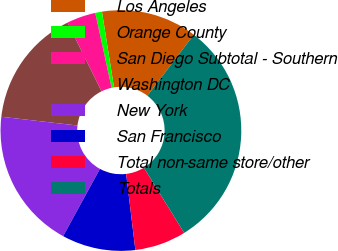<chart> <loc_0><loc_0><loc_500><loc_500><pie_chart><fcel>Los Angeles<fcel>Orange County<fcel>San Diego Subtotal - Southern<fcel>Washington DC<fcel>New York<fcel>San Francisco<fcel>Total non-same store/other<fcel>Totals<nl><fcel>12.87%<fcel>0.9%<fcel>3.89%<fcel>15.87%<fcel>18.86%<fcel>9.88%<fcel>6.89%<fcel>30.84%<nl></chart> 